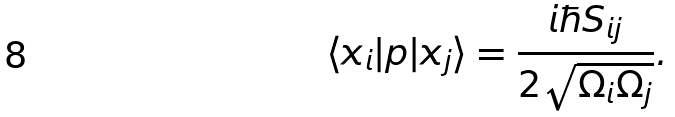<formula> <loc_0><loc_0><loc_500><loc_500>\langle x _ { i } | p | x _ { j } \rangle = \frac { i \hbar { S } _ { i j } } { 2 \sqrt { \Omega _ { i } \Omega _ { j } } } .</formula> 